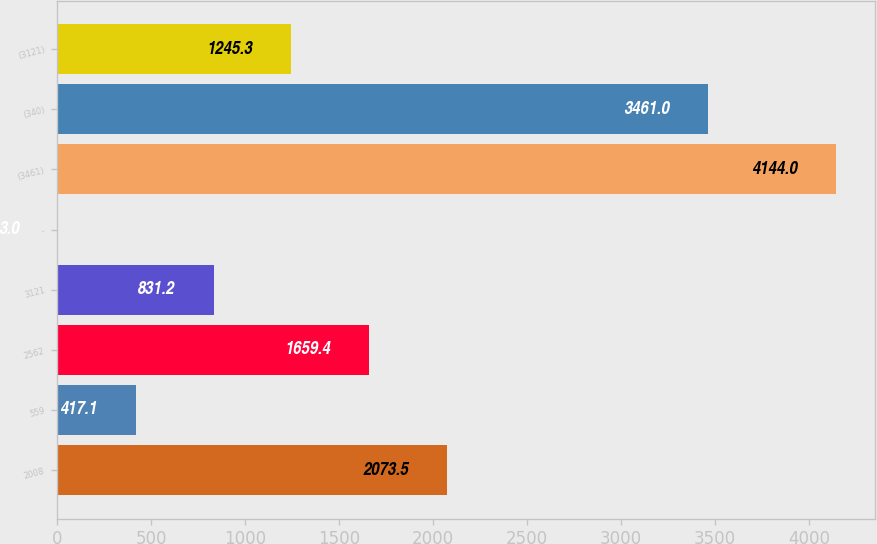Convert chart. <chart><loc_0><loc_0><loc_500><loc_500><bar_chart><fcel>2008<fcel>559<fcel>2562<fcel>3121<fcel>-<fcel>(3461)<fcel>(340)<fcel>(3121)<nl><fcel>2073.5<fcel>417.1<fcel>1659.4<fcel>831.2<fcel>3<fcel>4144<fcel>3461<fcel>1245.3<nl></chart> 